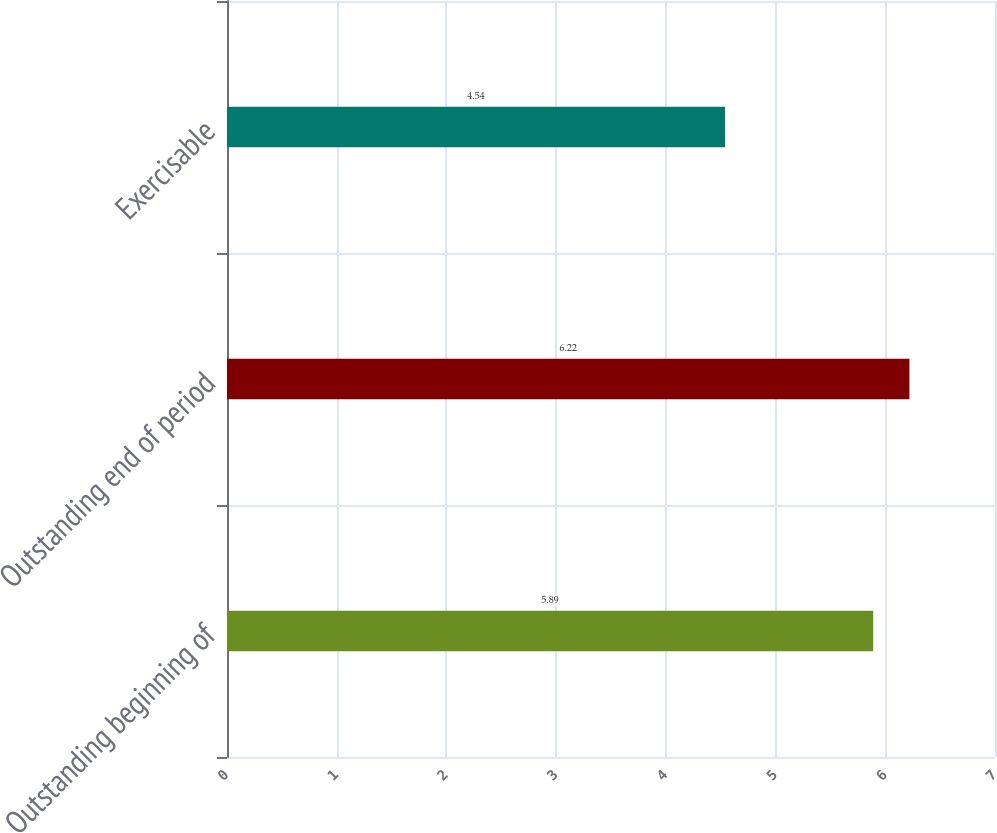Convert chart to OTSL. <chart><loc_0><loc_0><loc_500><loc_500><bar_chart><fcel>Outstanding beginning of<fcel>Outstanding end of period<fcel>Exercisable<nl><fcel>5.89<fcel>6.22<fcel>4.54<nl></chart> 